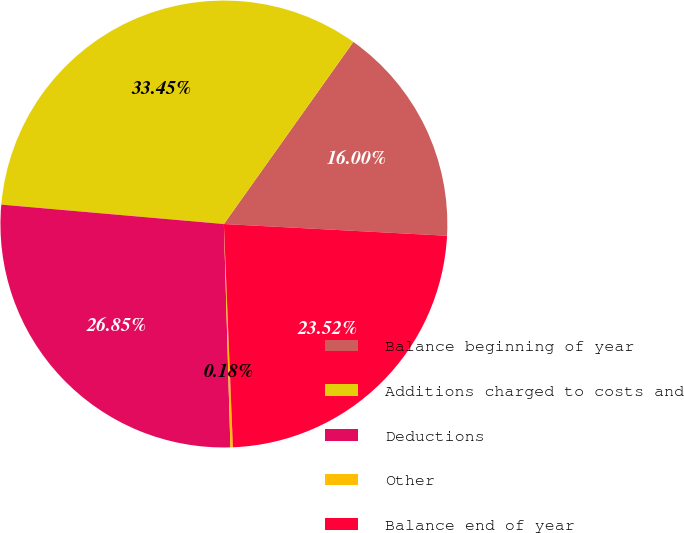Convert chart. <chart><loc_0><loc_0><loc_500><loc_500><pie_chart><fcel>Balance beginning of year<fcel>Additions charged to costs and<fcel>Deductions<fcel>Other<fcel>Balance end of year<nl><fcel>16.0%<fcel>33.45%<fcel>26.85%<fcel>0.18%<fcel>23.52%<nl></chart> 